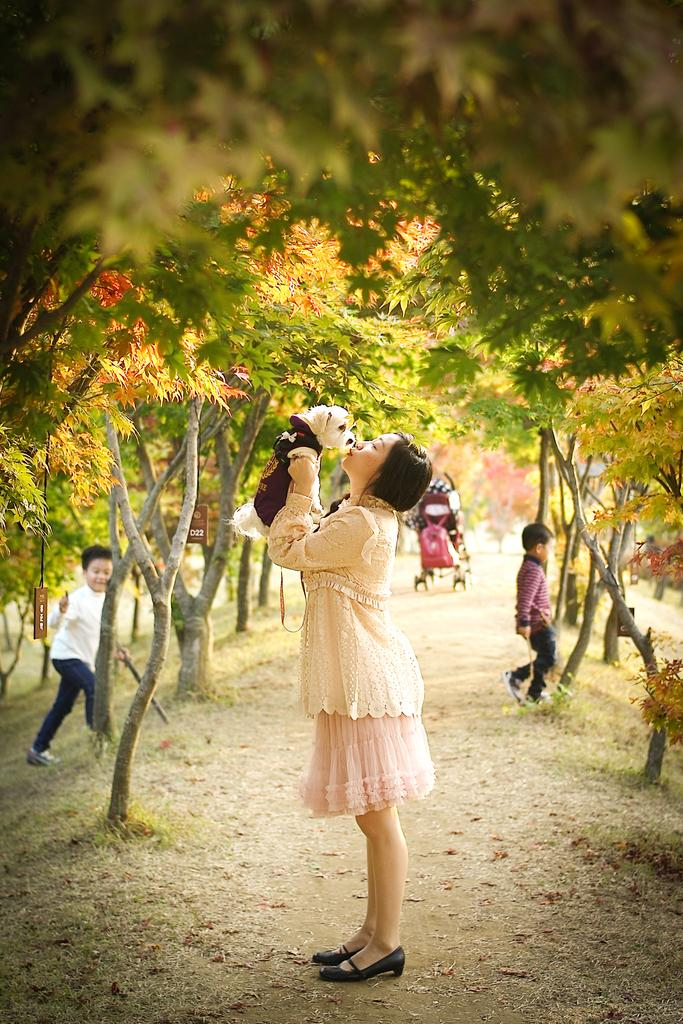How many people are present in the image? There are three people in the image. What else can be seen in the image besides the people? There is an animal and many trees in the background of the image. Can you describe the setting of the image? The image appears to be set in a natural environment with many trees in the background. What else is visible in the background of the image? There is a stroller in the background of the image. What type of key is being used to open the window in the image? There is no window or key present in the image. 